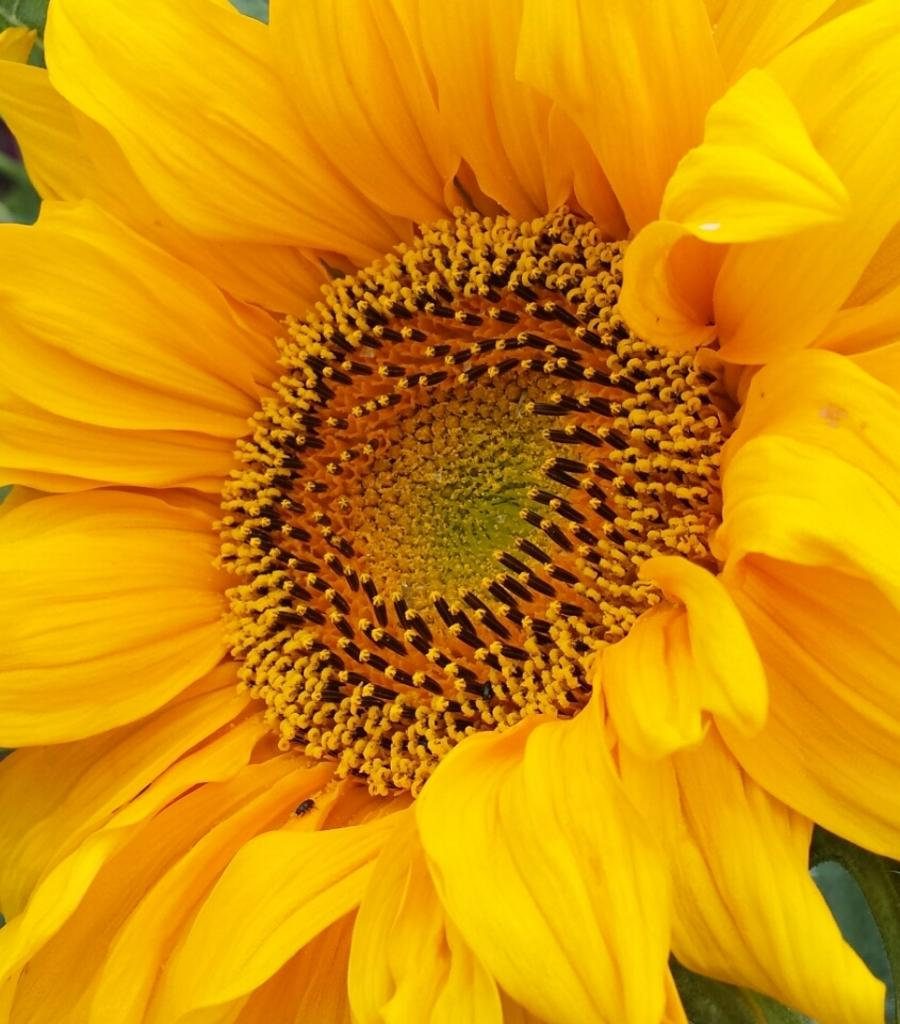What type of flower is present in the image? There is a yellow flower in the image. Are there any unopened parts on the flower? Yes, the flower has some buds. What other living organisms can be seen in the image? There are bugs in the image. What colors are the bugs? The bugs are in yellow and black colors. What type of sock is hanging from the flower in the image? There is no sock present in the image; it only features a yellow flower with buds and bugs. What amusement park can be seen in the background of the image? There is no amusement park visible in the image; it only contains a yellow flower, buds, and bugs. 